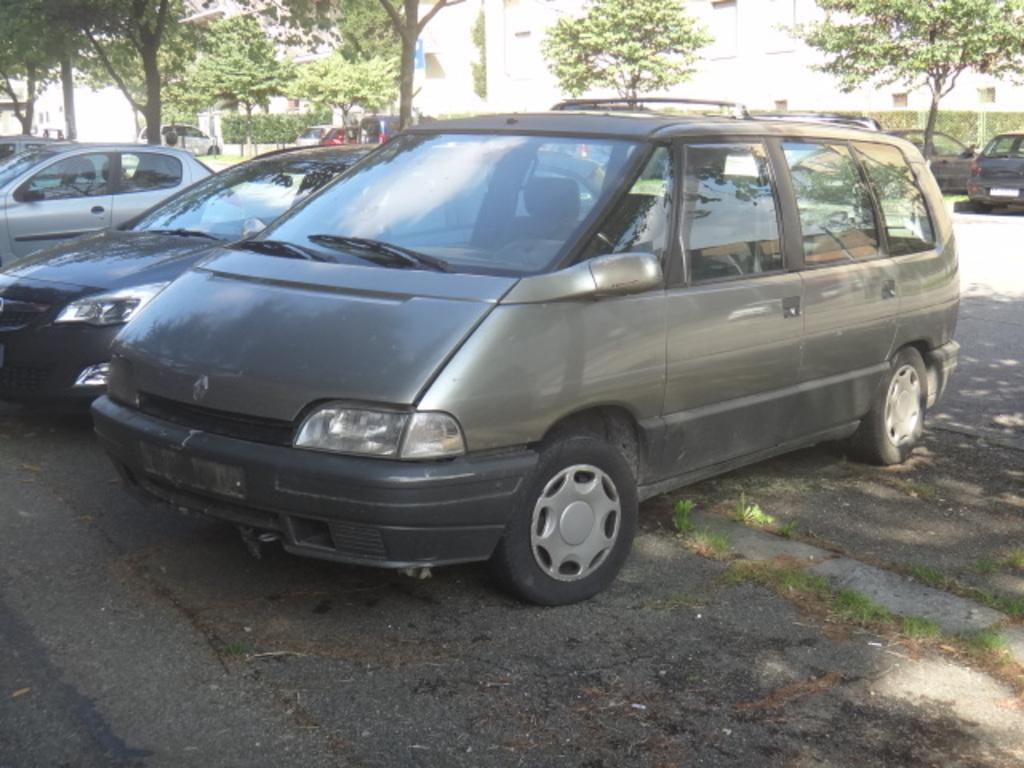What can be seen on the ground in the image? There is a group of cars parked on the ground. What type of vegetation is visible in the image? There is grass, trees, and plants visible in the image. What is the purpose of the board in the image? The purpose of the board is not clear from the image, but it could be a sign or notice. What type of structure is present in the image? There is a fence and buildings visible in the image. Can you tell me which eye is larger in the image? There are no eyes present in the image; it features a group of cars, grass, a board, trees, plants, a fence, and buildings. What type of vacation is being advertised on the board in the image? There is no vacation being advertised on the board in the image; it is not clear what the purpose of the board is. 